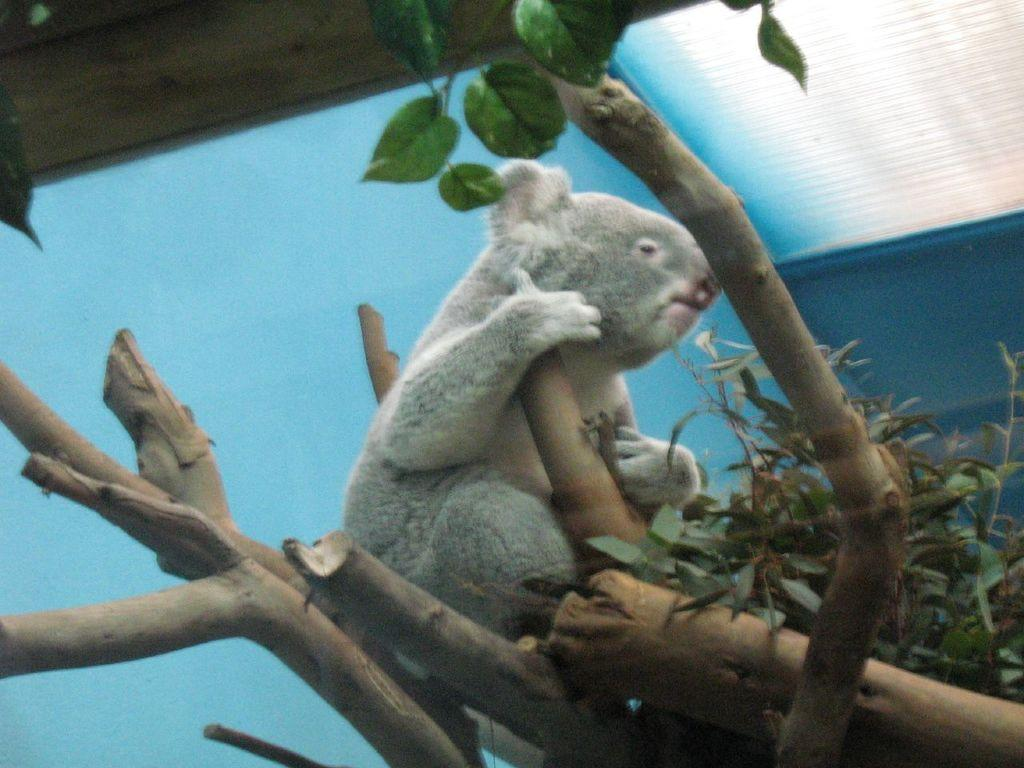What type of animal can be seen in the image? There is an animal in the image, but its specific type cannot be determined from the provided facts. Where is the animal located in the image? The animal is sitting on a tree in the image. What can be seen on the tree in the image? Leaves are visible in the image. What color is the background of the image? The background of the image is blue. Can you tell me where the nearest shop is located in the image? There is no information about a shop in the image, so it cannot be determined from the provided facts. 